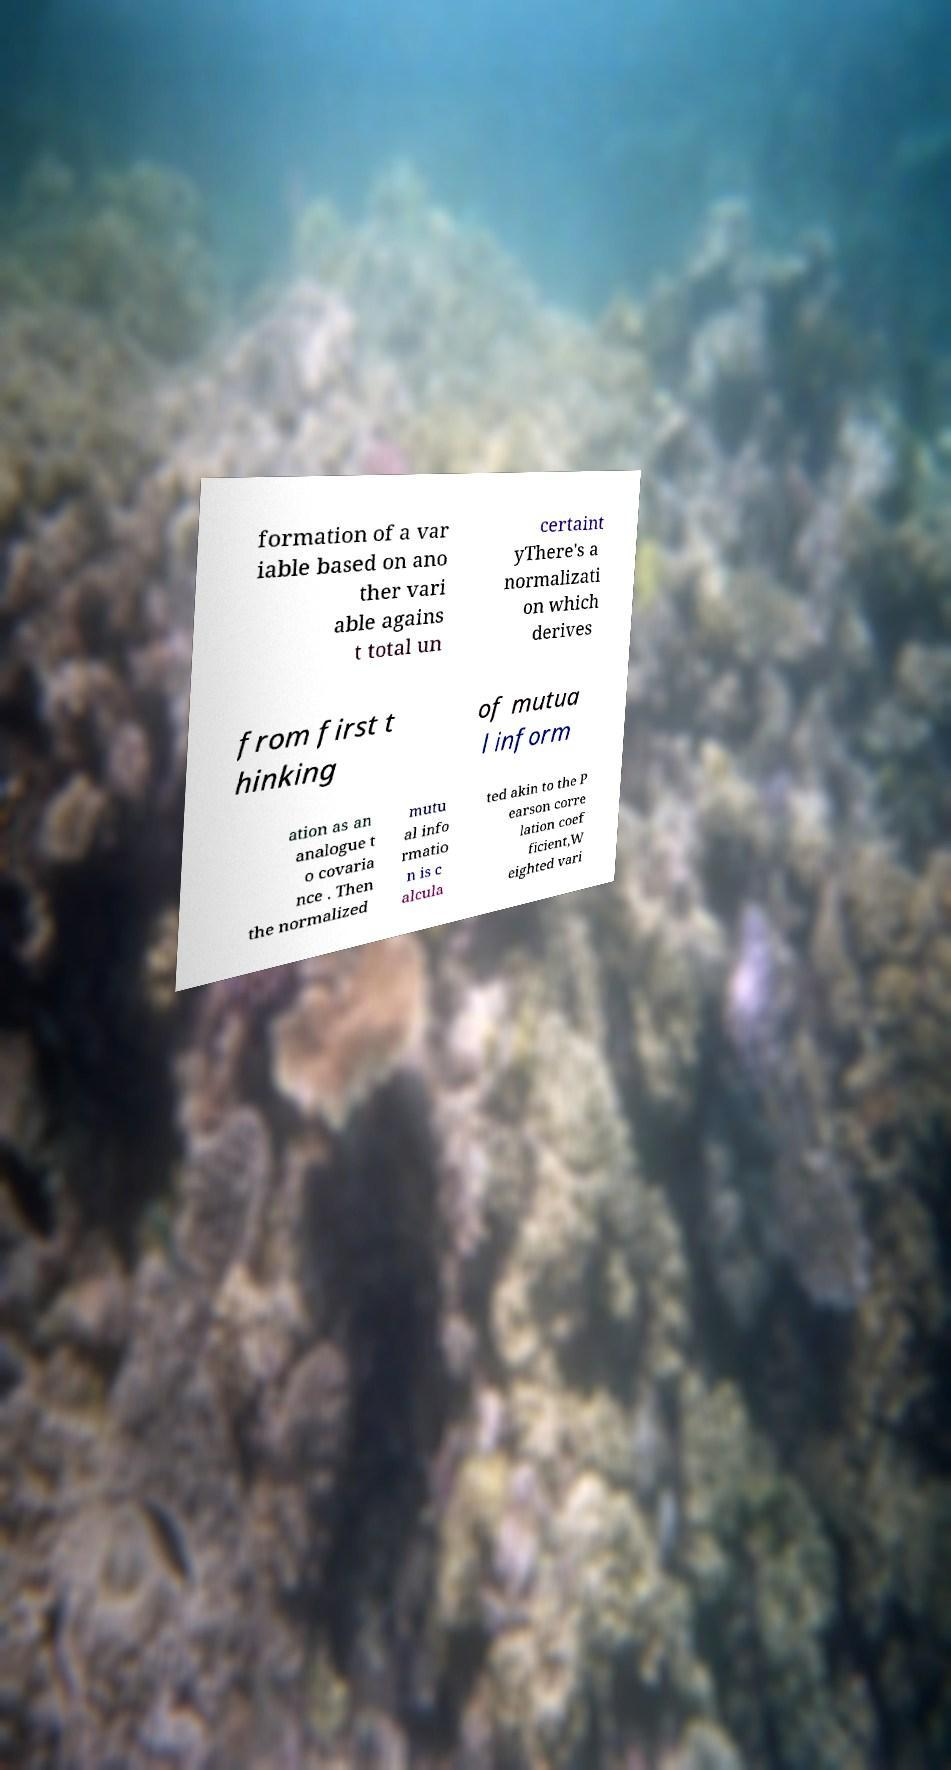What messages or text are displayed in this image? I need them in a readable, typed format. formation of a var iable based on ano ther vari able agains t total un certaint yThere's a normalizati on which derives from first t hinking of mutua l inform ation as an analogue t o covaria nce . Then the normalized mutu al info rmatio n is c alcula ted akin to the P earson corre lation coef ficient,W eighted vari 